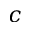<formula> <loc_0><loc_0><loc_500><loc_500>c</formula> 